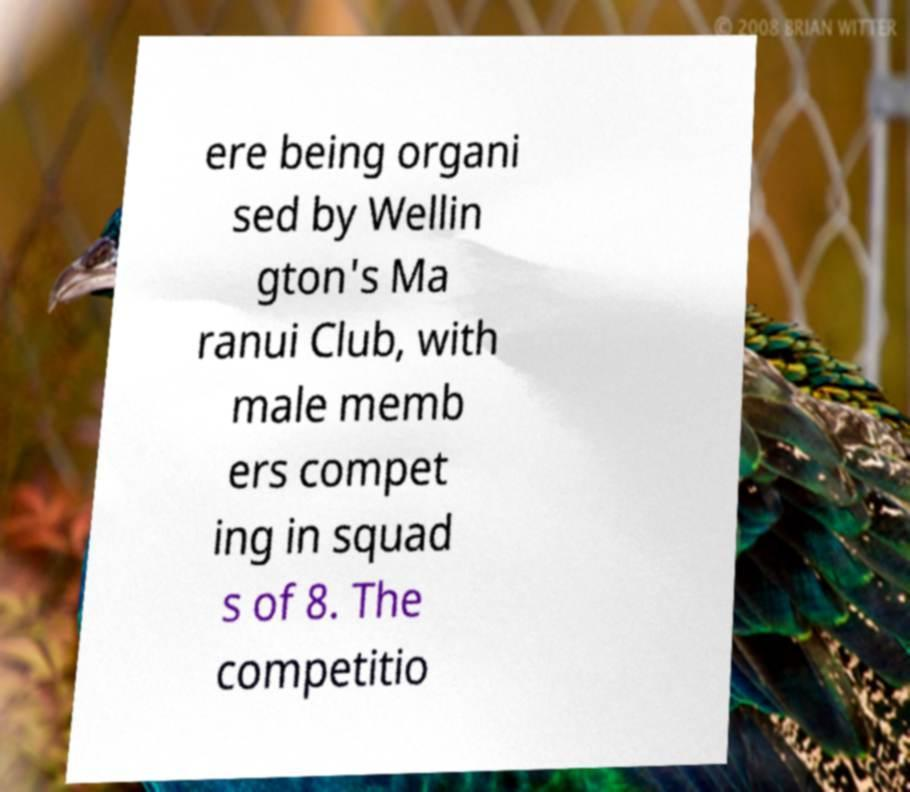For documentation purposes, I need the text within this image transcribed. Could you provide that? ere being organi sed by Wellin gton's Ma ranui Club, with male memb ers compet ing in squad s of 8. The competitio 